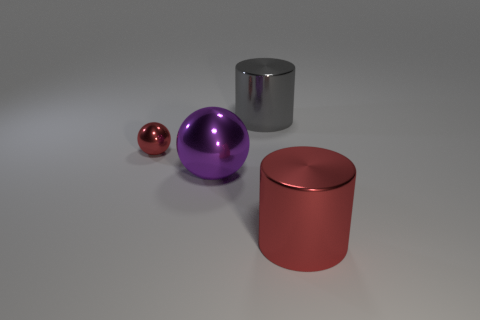Add 1 big blue metal balls. How many objects exist? 5 Add 2 red objects. How many red objects exist? 4 Subtract 0 green cylinders. How many objects are left? 4 Subtract all small yellow rubber things. Subtract all large metal balls. How many objects are left? 3 Add 2 tiny red balls. How many tiny red balls are left? 3 